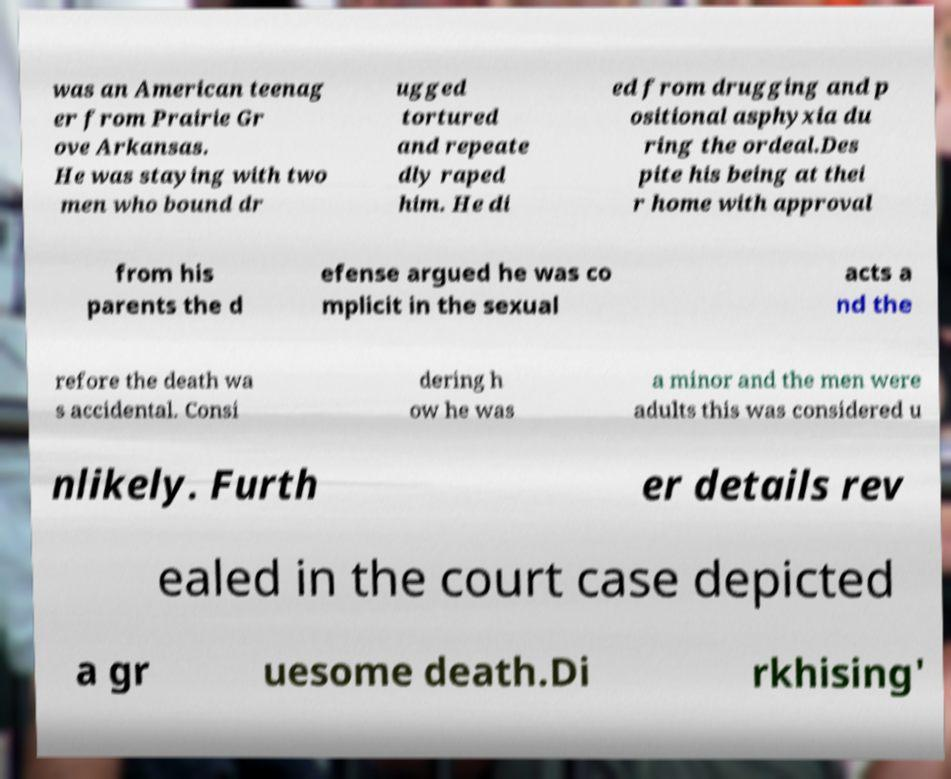For documentation purposes, I need the text within this image transcribed. Could you provide that? was an American teenag er from Prairie Gr ove Arkansas. He was staying with two men who bound dr ugged tortured and repeate dly raped him. He di ed from drugging and p ositional asphyxia du ring the ordeal.Des pite his being at thei r home with approval from his parents the d efense argued he was co mplicit in the sexual acts a nd the refore the death wa s accidental. Consi dering h ow he was a minor and the men were adults this was considered u nlikely. Furth er details rev ealed in the court case depicted a gr uesome death.Di rkhising' 